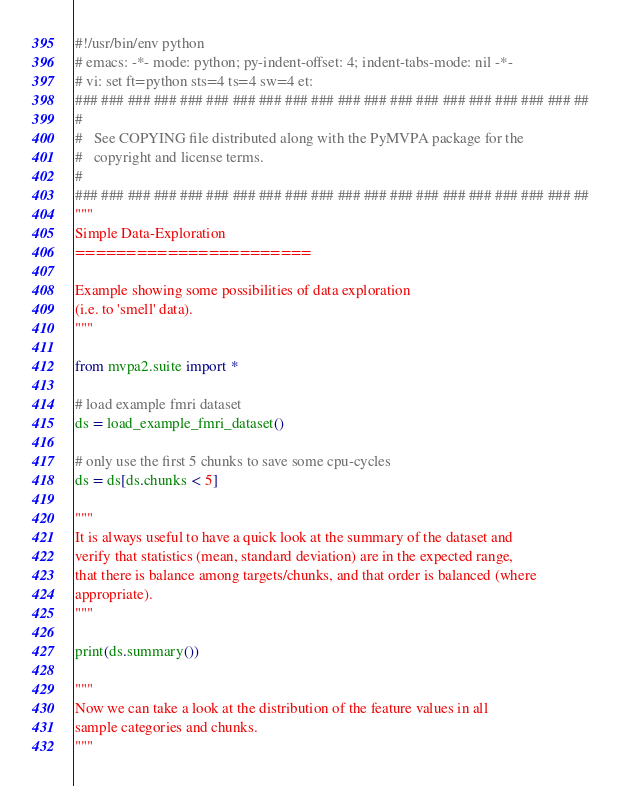<code> <loc_0><loc_0><loc_500><loc_500><_Python_>#!/usr/bin/env python
# emacs: -*- mode: python; py-indent-offset: 4; indent-tabs-mode: nil -*-
# vi: set ft=python sts=4 ts=4 sw=4 et:
### ### ### ### ### ### ### ### ### ### ### ### ### ### ### ### ### ### ### ##
#
#   See COPYING file distributed along with the PyMVPA package for the
#   copyright and license terms.
#
### ### ### ### ### ### ### ### ### ### ### ### ### ### ### ### ### ### ### ##
"""
Simple Data-Exploration
=======================

Example showing some possibilities of data exploration
(i.e. to 'smell' data).
"""

from mvpa2.suite import *

# load example fmri dataset
ds = load_example_fmri_dataset()

# only use the first 5 chunks to save some cpu-cycles
ds = ds[ds.chunks < 5]

"""
It is always useful to have a quick look at the summary of the dataset and
verify that statistics (mean, standard deviation) are in the expected range,
that there is balance among targets/chunks, and that order is balanced (where
appropriate).
"""

print(ds.summary())

"""
Now we can take a look at the distribution of the feature values in all
sample categories and chunks.
"""
</code> 